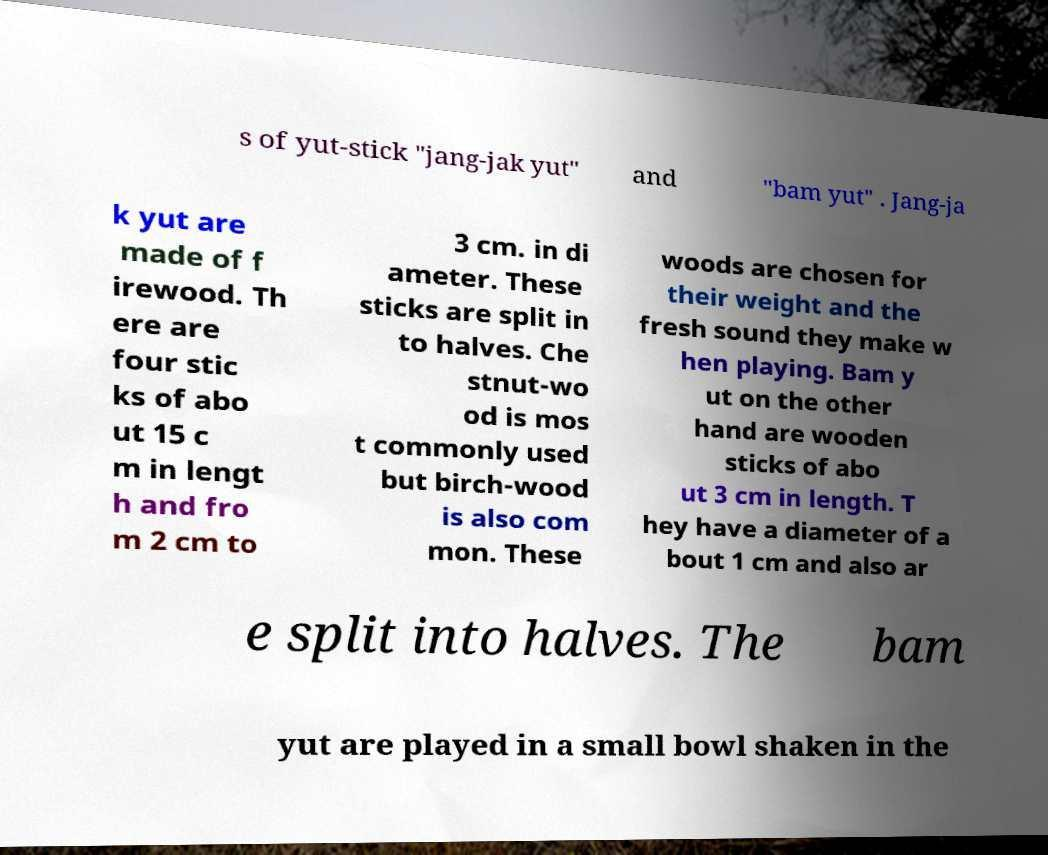Could you assist in decoding the text presented in this image and type it out clearly? s of yut-stick "jang-jak yut" and "bam yut" . Jang-ja k yut are made of f irewood. Th ere are four stic ks of abo ut 15 c m in lengt h and fro m 2 cm to 3 cm. in di ameter. These sticks are split in to halves. Che stnut-wo od is mos t commonly used but birch-wood is also com mon. These woods are chosen for their weight and the fresh sound they make w hen playing. Bam y ut on the other hand are wooden sticks of abo ut 3 cm in length. T hey have a diameter of a bout 1 cm and also ar e split into halves. The bam yut are played in a small bowl shaken in the 